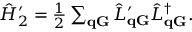<formula> <loc_0><loc_0><loc_500><loc_500>\begin{array} { r } { \hat { H } _ { 2 } ^ { \prime } = \frac { 1 } { 2 } \sum _ { \mathbf q \mathbf G } \hat { L } _ { q G } ^ { \prime } \hat { L } _ { q G } ^ { \dagger } . } \end{array}</formula> 